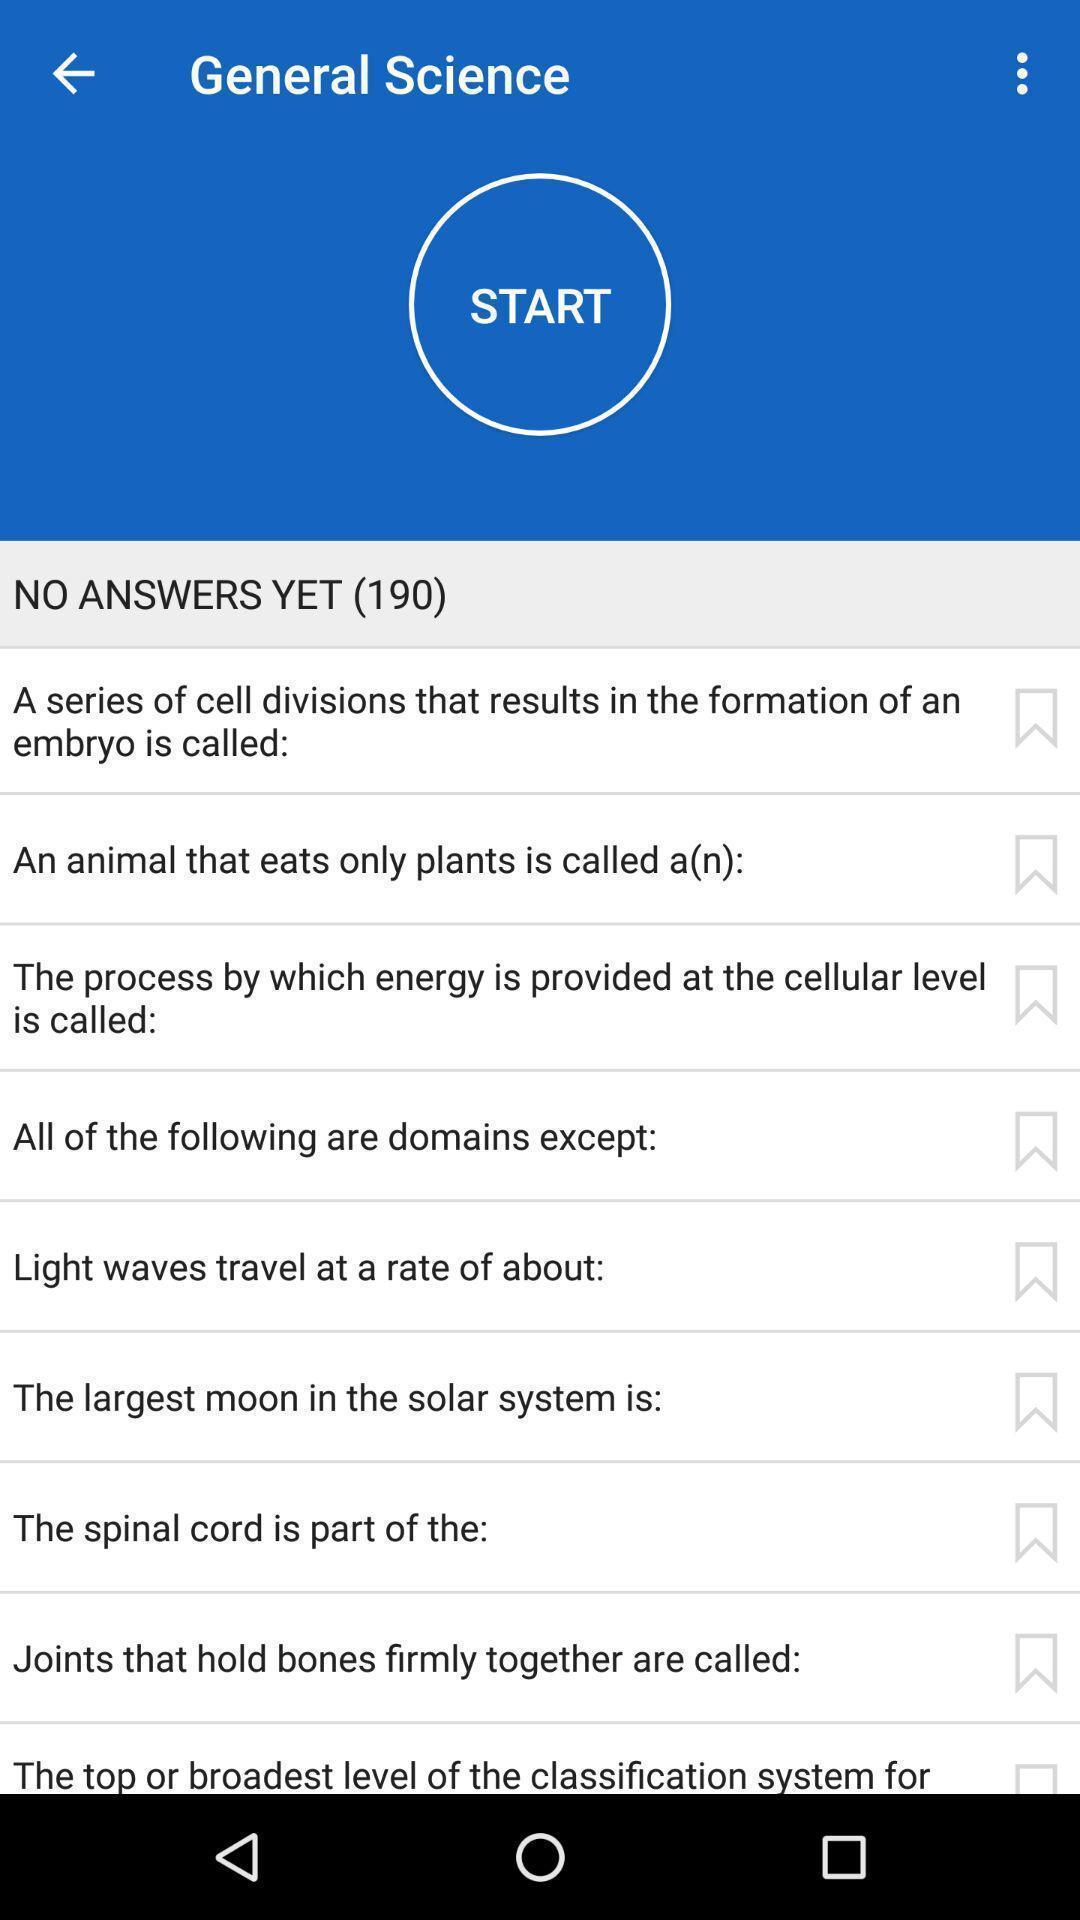Describe the visual elements of this screenshot. Page displaying with list of different science related questions. 